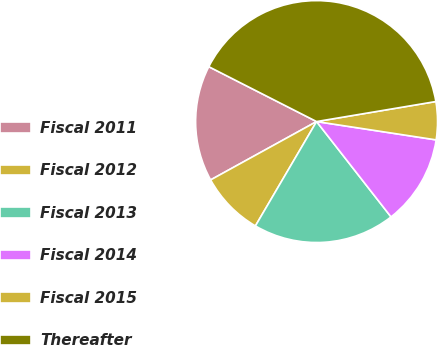Convert chart to OTSL. <chart><loc_0><loc_0><loc_500><loc_500><pie_chart><fcel>Fiscal 2011<fcel>Fiscal 2012<fcel>Fiscal 2013<fcel>Fiscal 2014<fcel>Fiscal 2015<fcel>Thereafter<nl><fcel>15.51%<fcel>8.55%<fcel>18.99%<fcel>12.03%<fcel>5.07%<fcel>39.86%<nl></chart> 